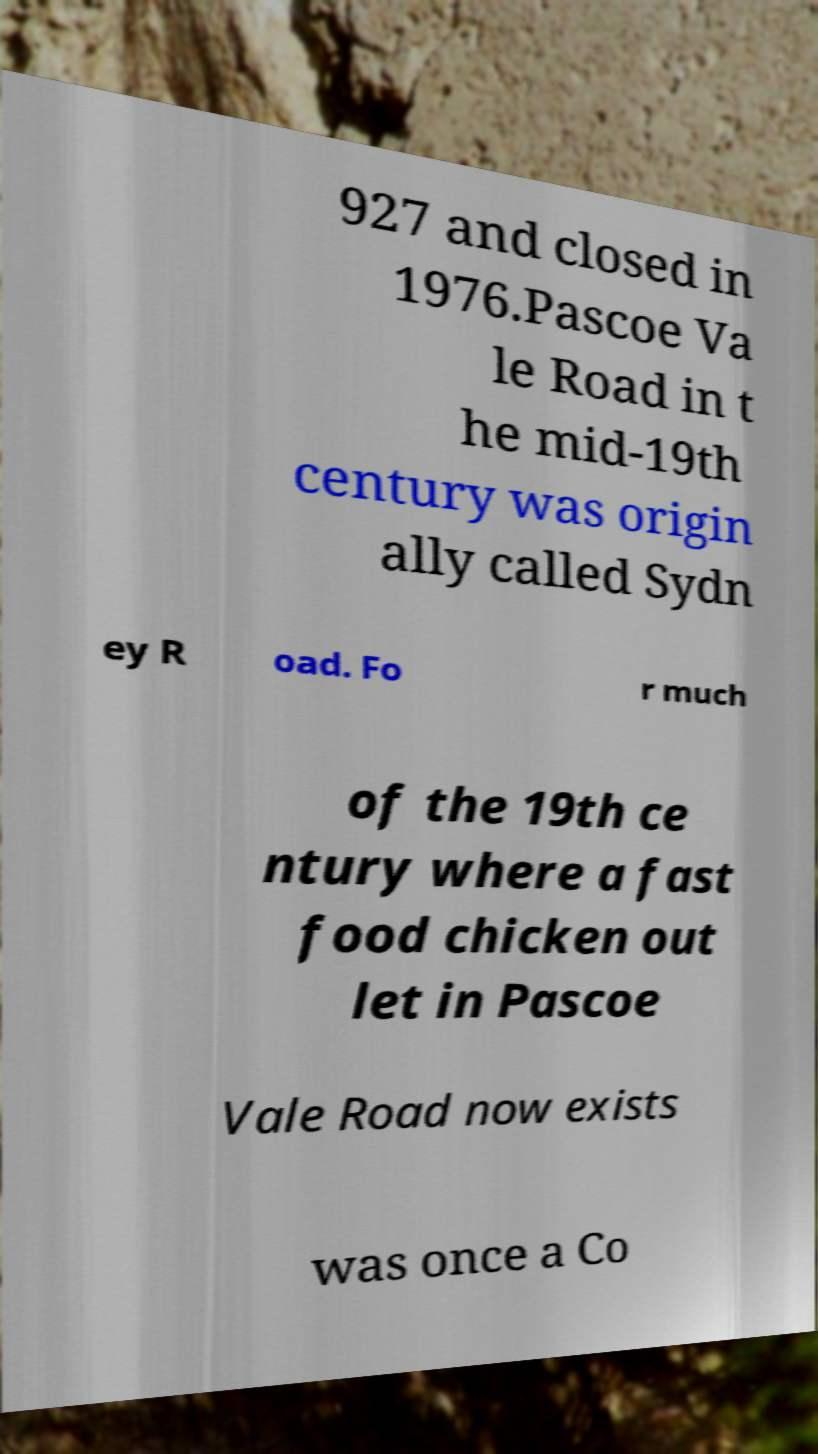I need the written content from this picture converted into text. Can you do that? 927 and closed in 1976.Pascoe Va le Road in t he mid-19th century was origin ally called Sydn ey R oad. Fo r much of the 19th ce ntury where a fast food chicken out let in Pascoe Vale Road now exists was once a Co 